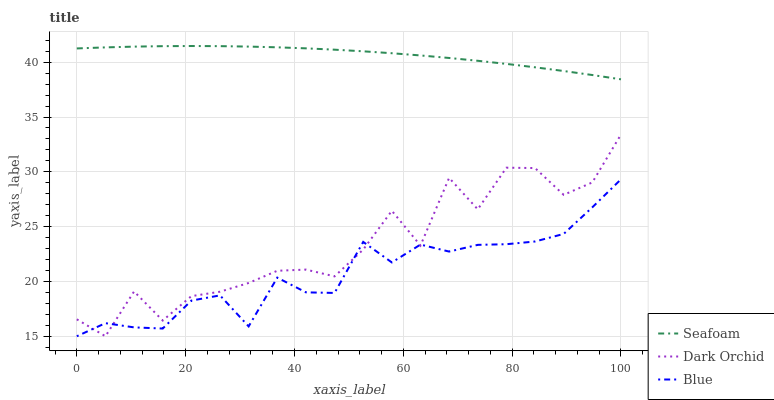Does Blue have the minimum area under the curve?
Answer yes or no. Yes. Does Seafoam have the maximum area under the curve?
Answer yes or no. Yes. Does Dark Orchid have the minimum area under the curve?
Answer yes or no. No. Does Dark Orchid have the maximum area under the curve?
Answer yes or no. No. Is Seafoam the smoothest?
Answer yes or no. Yes. Is Dark Orchid the roughest?
Answer yes or no. Yes. Is Dark Orchid the smoothest?
Answer yes or no. No. Is Seafoam the roughest?
Answer yes or no. No. Does Blue have the lowest value?
Answer yes or no. Yes. Does Seafoam have the lowest value?
Answer yes or no. No. Does Seafoam have the highest value?
Answer yes or no. Yes. Does Dark Orchid have the highest value?
Answer yes or no. No. Is Dark Orchid less than Seafoam?
Answer yes or no. Yes. Is Seafoam greater than Blue?
Answer yes or no. Yes. Does Blue intersect Dark Orchid?
Answer yes or no. Yes. Is Blue less than Dark Orchid?
Answer yes or no. No. Is Blue greater than Dark Orchid?
Answer yes or no. No. Does Dark Orchid intersect Seafoam?
Answer yes or no. No. 